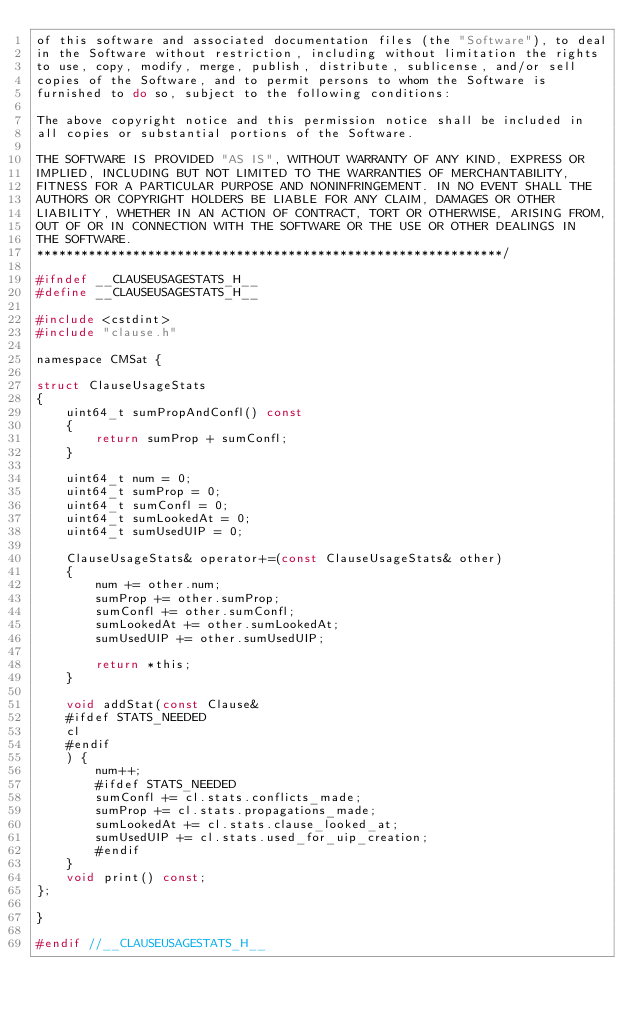Convert code to text. <code><loc_0><loc_0><loc_500><loc_500><_C_>of this software and associated documentation files (the "Software"), to deal
in the Software without restriction, including without limitation the rights
to use, copy, modify, merge, publish, distribute, sublicense, and/or sell
copies of the Software, and to permit persons to whom the Software is
furnished to do so, subject to the following conditions:

The above copyright notice and this permission notice shall be included in
all copies or substantial portions of the Software.

THE SOFTWARE IS PROVIDED "AS IS", WITHOUT WARRANTY OF ANY KIND, EXPRESS OR
IMPLIED, INCLUDING BUT NOT LIMITED TO THE WARRANTIES OF MERCHANTABILITY,
FITNESS FOR A PARTICULAR PURPOSE AND NONINFRINGEMENT. IN NO EVENT SHALL THE
AUTHORS OR COPYRIGHT HOLDERS BE LIABLE FOR ANY CLAIM, DAMAGES OR OTHER
LIABILITY, WHETHER IN AN ACTION OF CONTRACT, TORT OR OTHERWISE, ARISING FROM,
OUT OF OR IN CONNECTION WITH THE SOFTWARE OR THE USE OR OTHER DEALINGS IN
THE SOFTWARE.
***************************************************************/

#ifndef __CLAUSEUSAGESTATS_H__
#define __CLAUSEUSAGESTATS_H__

#include <cstdint>
#include "clause.h"

namespace CMSat {

struct ClauseUsageStats
{
    uint64_t sumPropAndConfl() const
    {
        return sumProp + sumConfl;
    }

    uint64_t num = 0;
    uint64_t sumProp = 0;
    uint64_t sumConfl = 0;
    uint64_t sumLookedAt = 0;
    uint64_t sumUsedUIP = 0;

    ClauseUsageStats& operator+=(const ClauseUsageStats& other)
    {
        num += other.num;
        sumProp += other.sumProp;
        sumConfl += other.sumConfl;
        sumLookedAt += other.sumLookedAt;
        sumUsedUIP += other.sumUsedUIP;

        return *this;
    }

    void addStat(const Clause&
    #ifdef STATS_NEEDED
    cl
    #endif
    ) {
        num++;
        #ifdef STATS_NEEDED
        sumConfl += cl.stats.conflicts_made;
        sumProp += cl.stats.propagations_made;
        sumLookedAt += cl.stats.clause_looked_at;
        sumUsedUIP += cl.stats.used_for_uip_creation;
        #endif
    }
    void print() const;
};

}

#endif //__CLAUSEUSAGESTATS_H__
</code> 